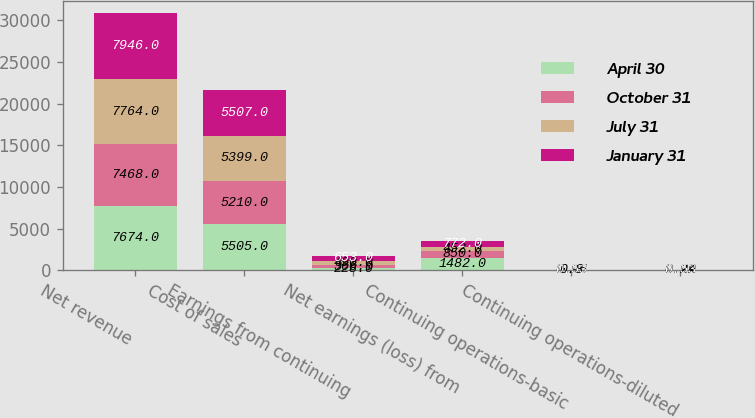Convert chart. <chart><loc_0><loc_0><loc_500><loc_500><stacked_bar_chart><ecel><fcel>Net revenue<fcel>Cost of sales<fcel>Earnings from continuing<fcel>Net earnings (loss) from<fcel>Continuing operations-basic<fcel>Continuing operations-diluted<nl><fcel>April 30<fcel>7674<fcel>5505<fcel>228<fcel>1482<fcel>0.93<fcel>0.92<nl><fcel>October 31<fcel>7468<fcel>5210<fcel>366<fcel>850<fcel>0.55<fcel>0.54<nl><fcel>July 31<fcel>7764<fcel>5399<fcel>490<fcel>452<fcel>0.3<fcel>0.29<nl><fcel>January 31<fcel>7946<fcel>5507<fcel>653<fcel>772<fcel>0.53<fcel>0.53<nl></chart> 